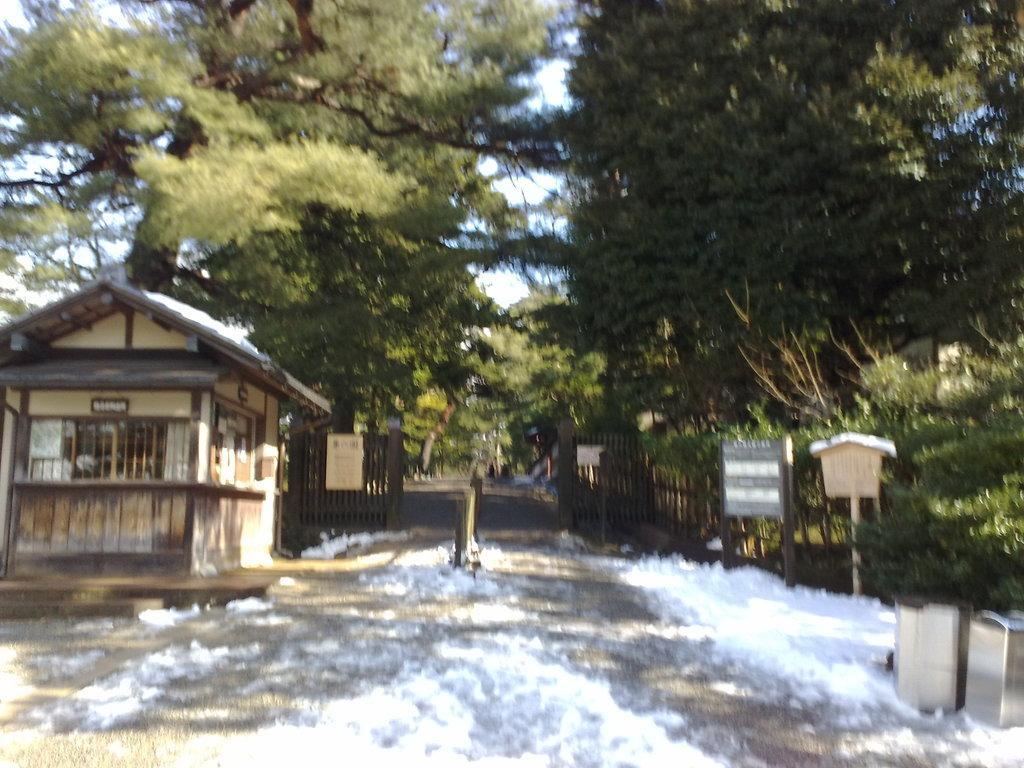How would you summarize this image in a sentence or two? In this picture we can see water on the ground, here we can see sheds, fence, name boards and some objects and in the background we can see trees, sky. 